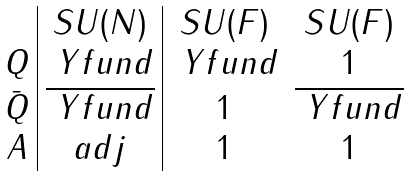<formula> <loc_0><loc_0><loc_500><loc_500>\begin{array} { c | c | c c } & S U ( N ) & S U ( F ) & S U ( F ) \\ Q & \ Y f u n d & \ Y f u n d & 1 \\ \bar { Q } & \overline { \ Y f u n d } & 1 & \overline { \ Y f u n d } \\ A & a d j & 1 & 1 \\ \end{array}</formula> 